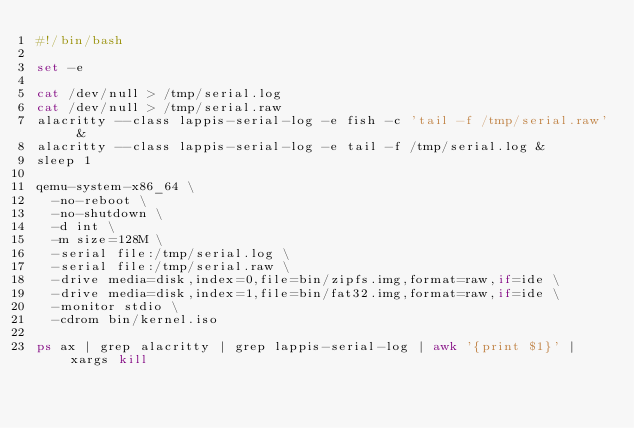<code> <loc_0><loc_0><loc_500><loc_500><_Bash_>#!/bin/bash

set -e

cat /dev/null > /tmp/serial.log
cat /dev/null > /tmp/serial.raw
alacritty --class lappis-serial-log -e fish -c 'tail -f /tmp/serial.raw' &
alacritty --class lappis-serial-log -e tail -f /tmp/serial.log &
sleep 1

qemu-system-x86_64 \
	-no-reboot \
	-no-shutdown \
	-d int \
	-m size=128M \
	-serial file:/tmp/serial.log \
	-serial file:/tmp/serial.raw \
	-drive media=disk,index=0,file=bin/zipfs.img,format=raw,if=ide \
	-drive media=disk,index=1,file=bin/fat32.img,format=raw,if=ide \
	-monitor stdio \
	-cdrom bin/kernel.iso

ps ax | grep alacritty | grep lappis-serial-log | awk '{print $1}' | xargs kill
</code> 